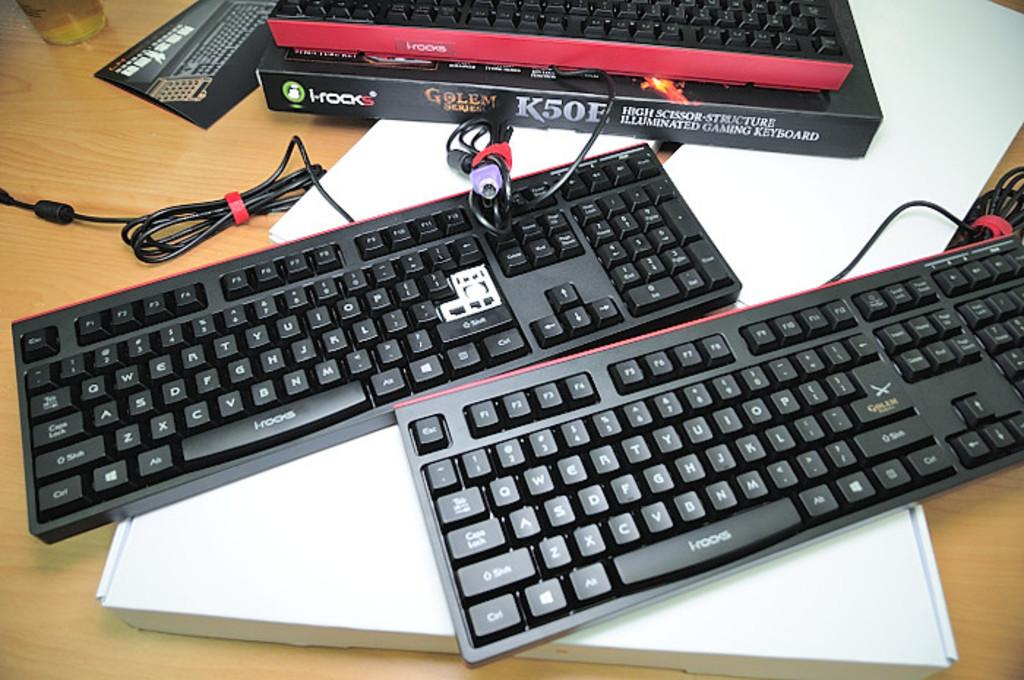Provide a one-sentence caption for the provided image. Two keyboards sit next to an i-rocks cardboard box. 